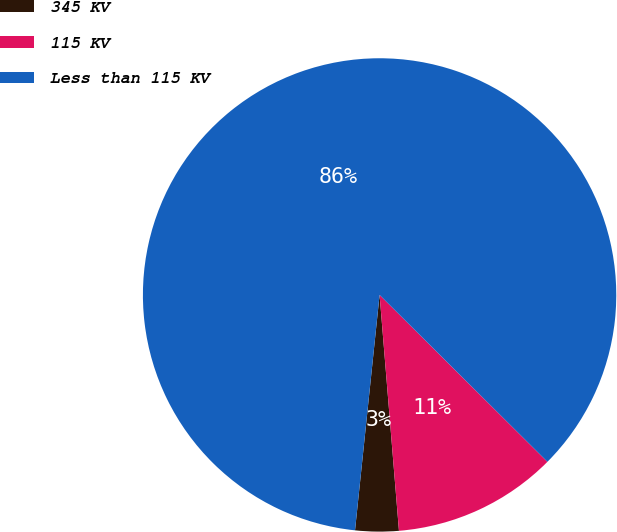Convert chart. <chart><loc_0><loc_0><loc_500><loc_500><pie_chart><fcel>345 KV<fcel>115 KV<fcel>Less than 115 KV<nl><fcel>2.96%<fcel>11.24%<fcel>85.8%<nl></chart> 